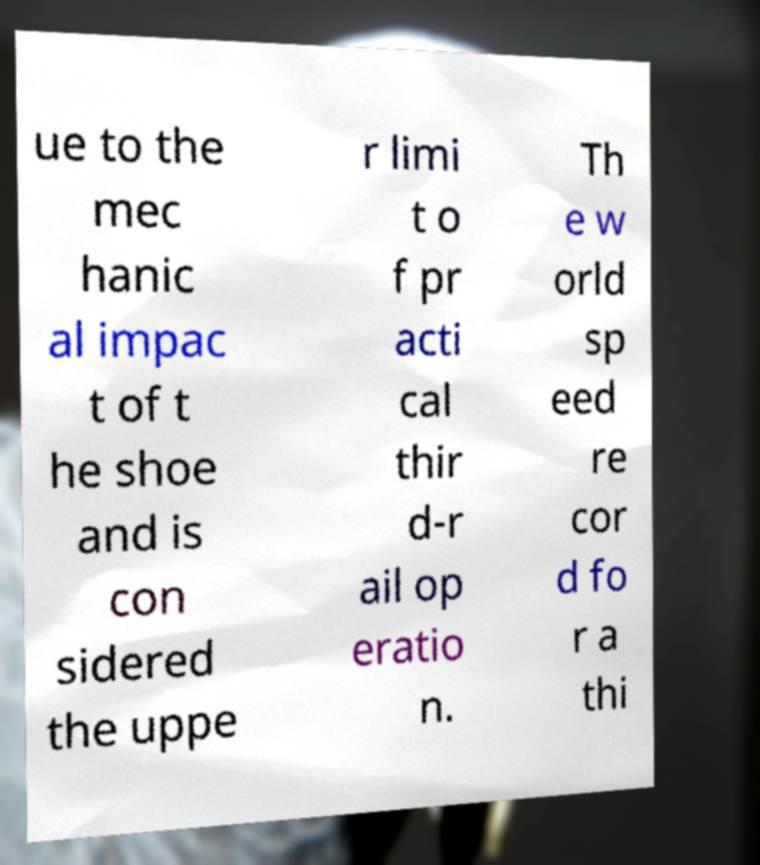I need the written content from this picture converted into text. Can you do that? ue to the mec hanic al impac t of t he shoe and is con sidered the uppe r limi t o f pr acti cal thir d-r ail op eratio n. Th e w orld sp eed re cor d fo r a thi 